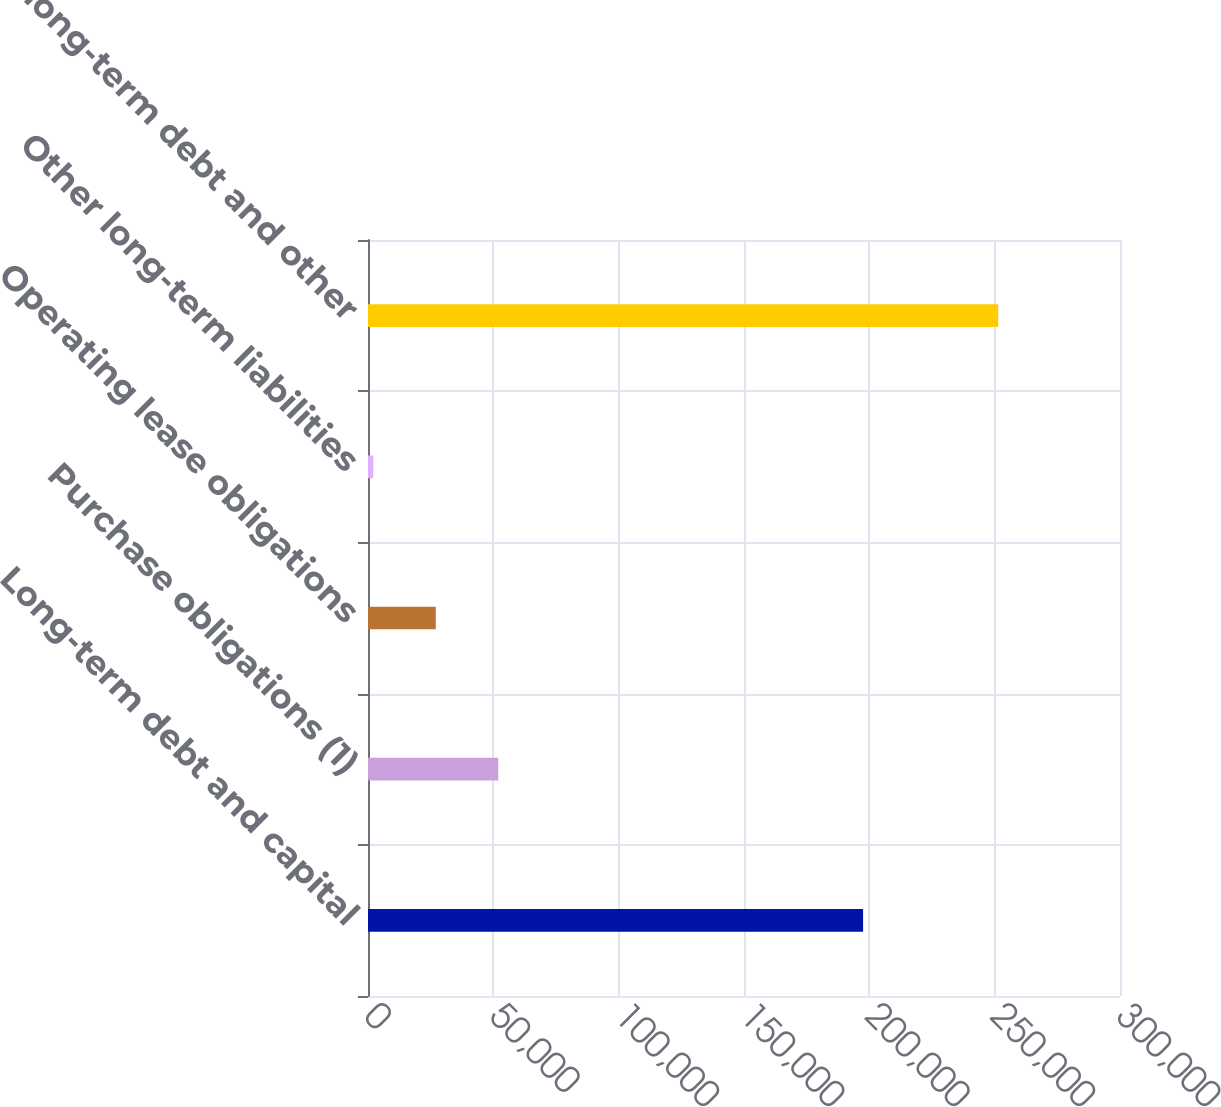Convert chart to OTSL. <chart><loc_0><loc_0><loc_500><loc_500><bar_chart><fcel>Long-term debt and capital<fcel>Purchase obligations (1)<fcel>Operating lease obligations<fcel>Other long-term liabilities<fcel>Total long-term debt and other<nl><fcel>197508<fcel>51962.8<fcel>27030.9<fcel>2099<fcel>251418<nl></chart> 